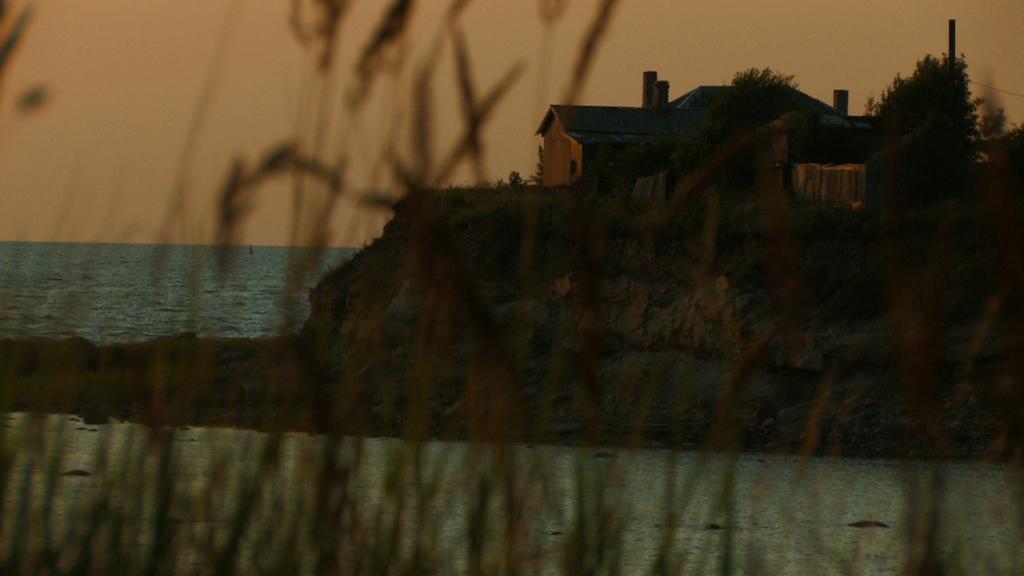Could you give a brief overview of what you see in this image? This is the picture of a sea. On the right side of the image there is a building and there are trees on the hill. On the left side of the image there is water. At the top there is sky. In the foreground there are plants. 